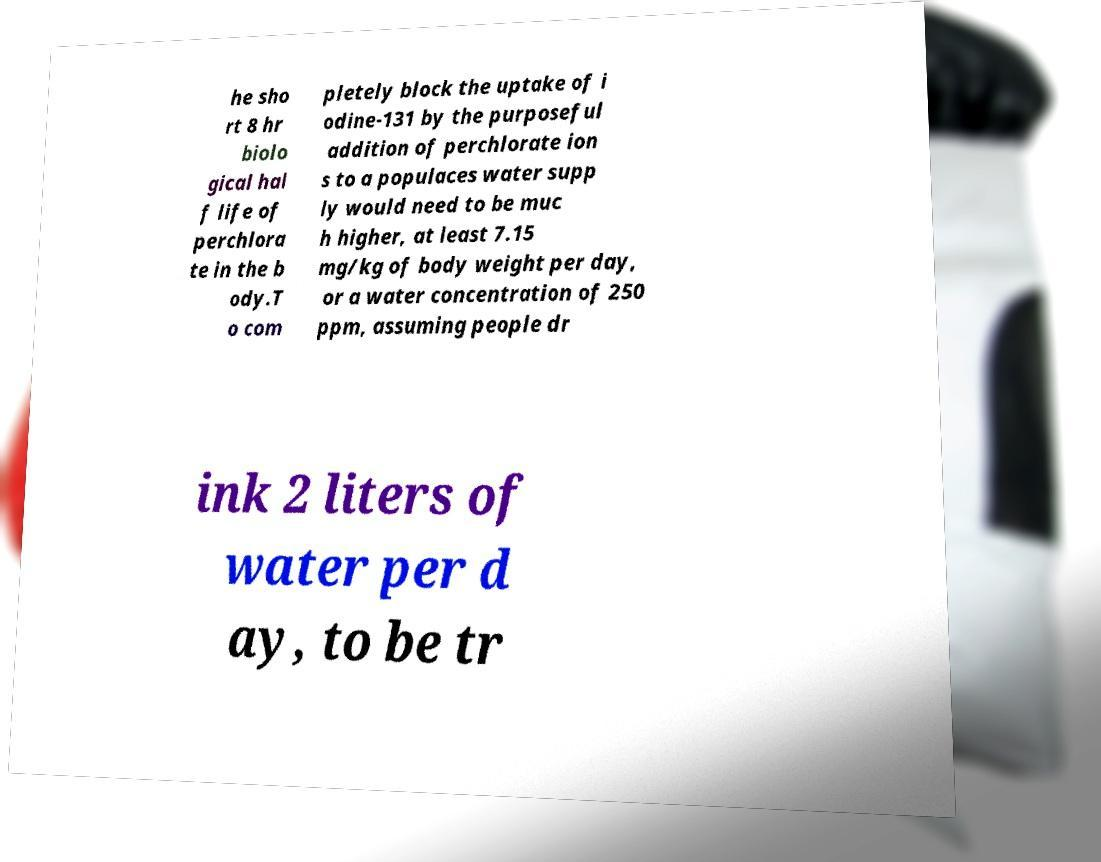Can you read and provide the text displayed in the image?This photo seems to have some interesting text. Can you extract and type it out for me? he sho rt 8 hr biolo gical hal f life of perchlora te in the b ody.T o com pletely block the uptake of i odine-131 by the purposeful addition of perchlorate ion s to a populaces water supp ly would need to be muc h higher, at least 7.15 mg/kg of body weight per day, or a water concentration of 250 ppm, assuming people dr ink 2 liters of water per d ay, to be tr 